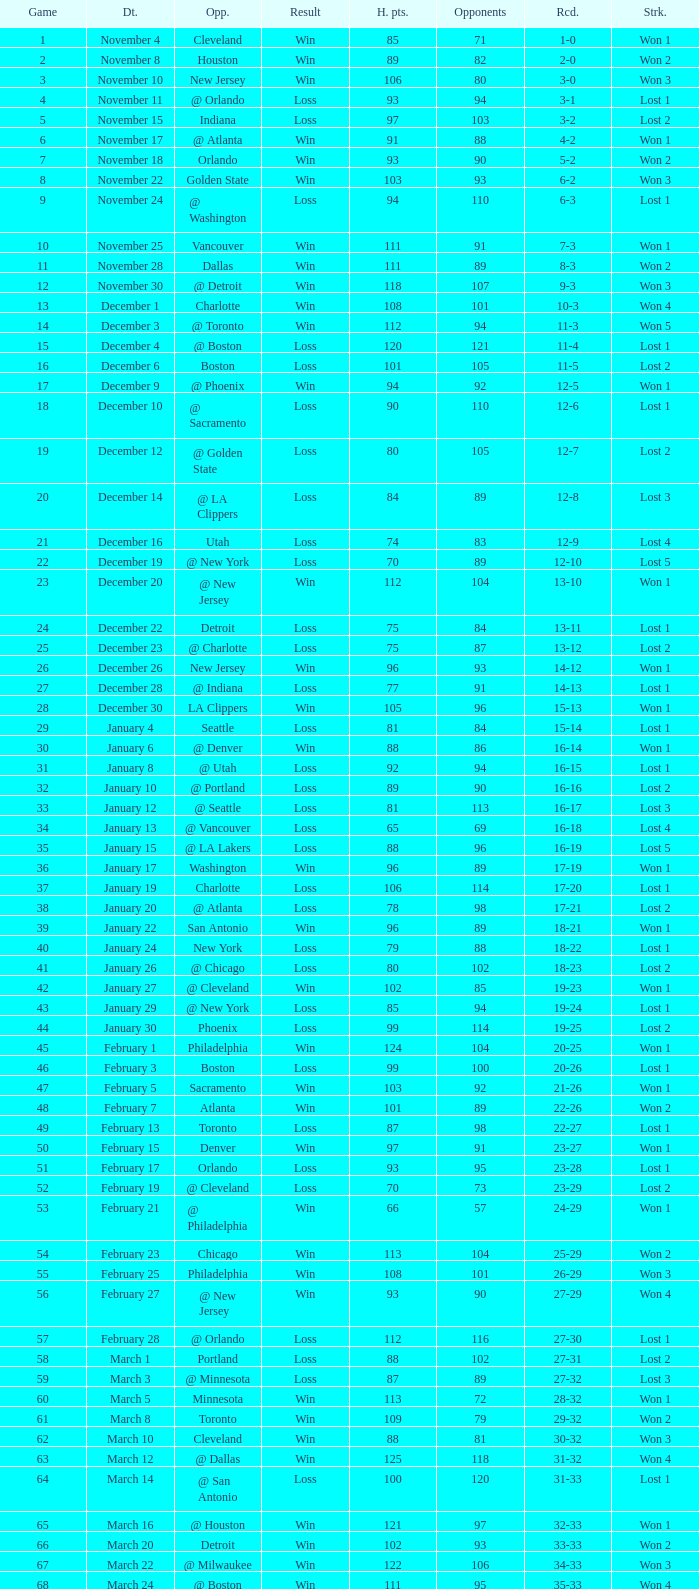What is Result, when Date is "December 12"? Loss. 